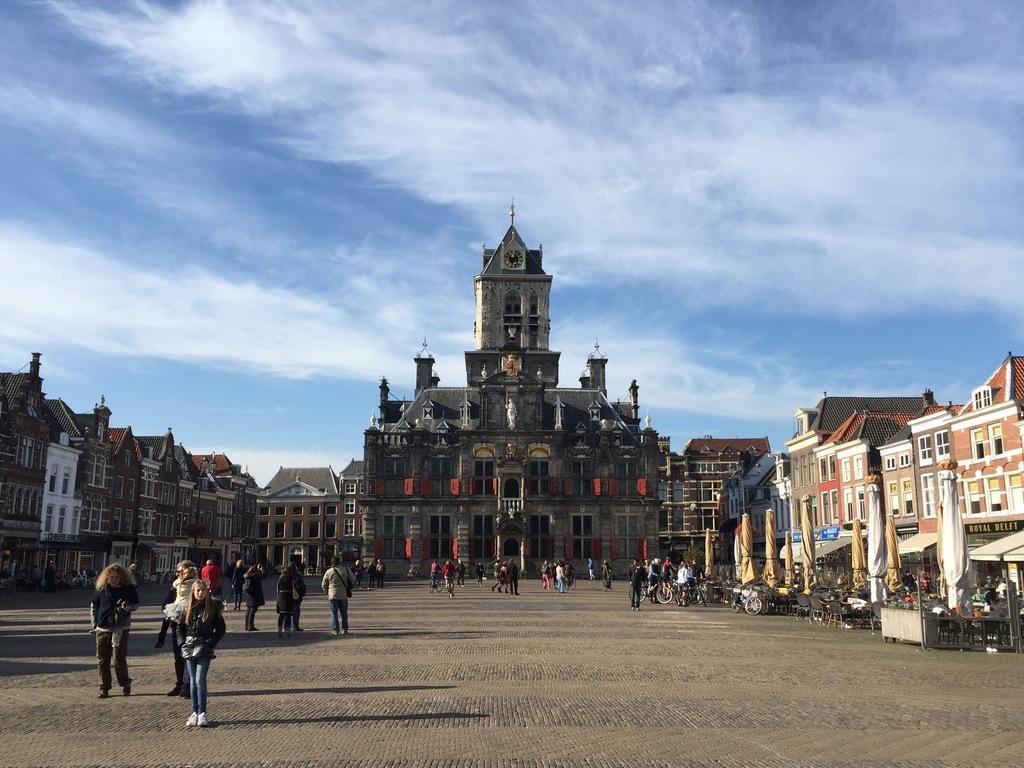Please provide a concise description of this image. In the image there are few people walking on the road with buildings on either side and a palace in the middle and above its sky with clouds. 